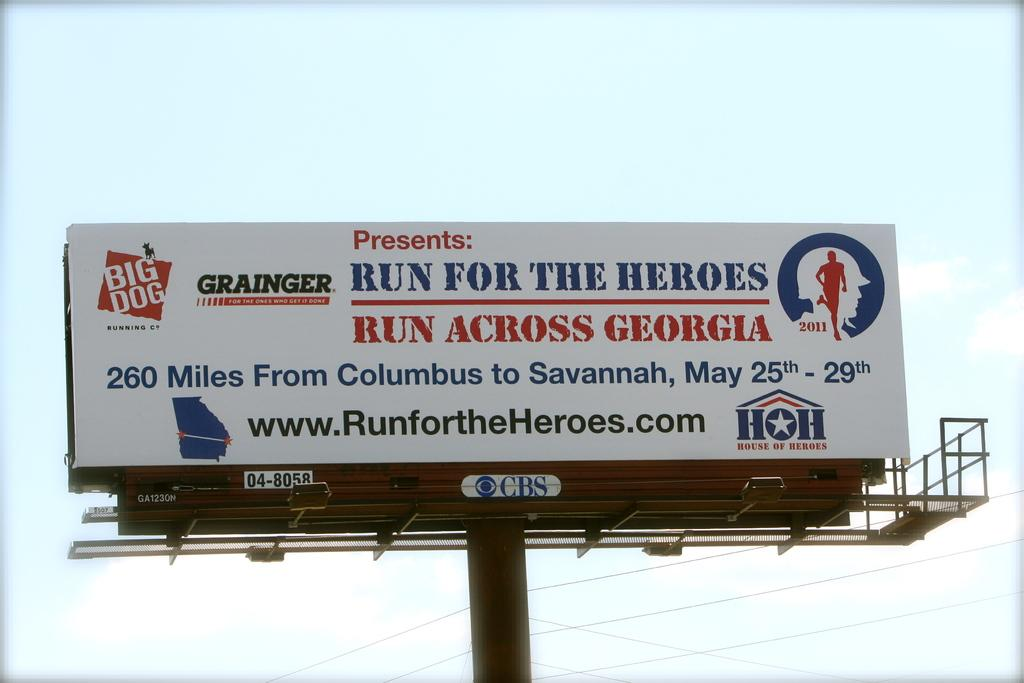<image>
Write a terse but informative summary of the picture. A billboard advertising an event called Run for the Heroes. 